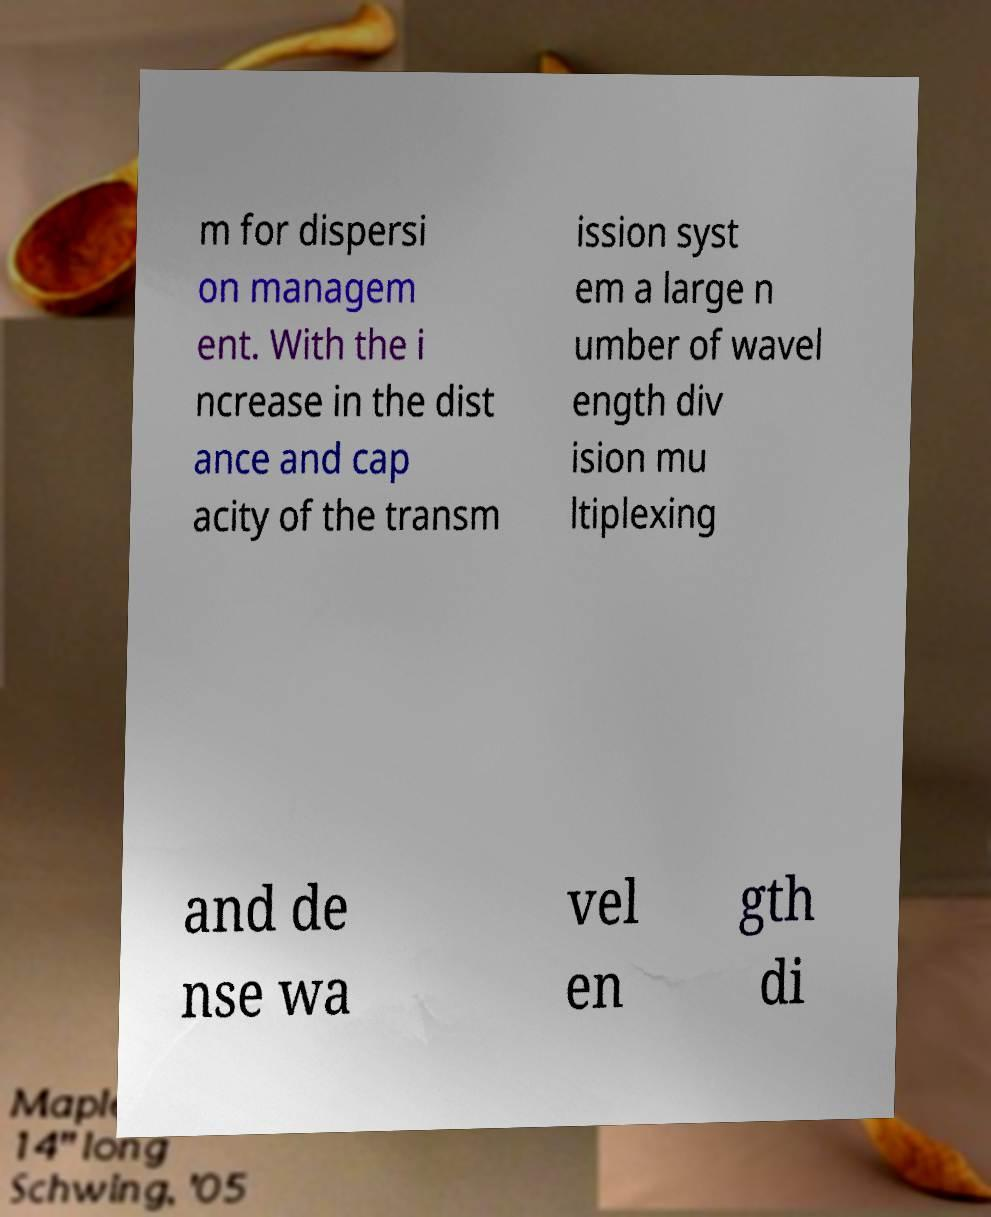Can you accurately transcribe the text from the provided image for me? m for dispersi on managem ent. With the i ncrease in the dist ance and cap acity of the transm ission syst em a large n umber of wavel ength div ision mu ltiplexing and de nse wa vel en gth di 